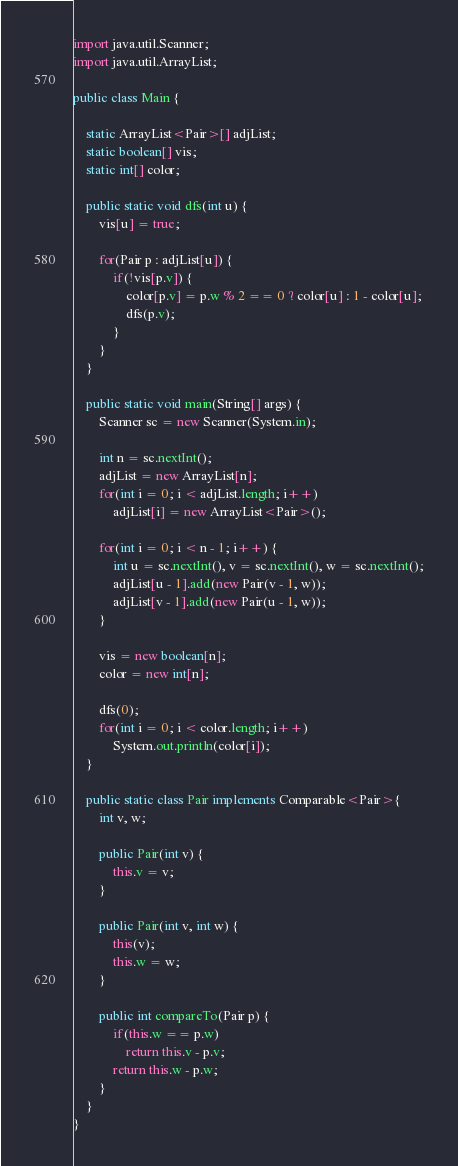Convert code to text. <code><loc_0><loc_0><loc_500><loc_500><_Java_>import java.util.Scanner;
import java.util.ArrayList;

public class Main {
	
	static ArrayList<Pair>[] adjList;
	static boolean[] vis;
	static int[] color;
	
	public static void dfs(int u) {
		vis[u] = true;
		
		for(Pair p : adjList[u]) {
			if(!vis[p.v]) {
				color[p.v] = p.w % 2 == 0 ? color[u] : 1 - color[u];
				dfs(p.v);
			}
		}
	}
	
	public static void main(String[] args) {
		Scanner sc = new Scanner(System.in);
		
		int n = sc.nextInt();
		adjList = new ArrayList[n];
		for(int i = 0; i < adjList.length; i++)
			adjList[i] = new ArrayList<Pair>();
		
		for(int i = 0; i < n - 1; i++) {
			int u = sc.nextInt(), v = sc.nextInt(), w = sc.nextInt();
			adjList[u - 1].add(new Pair(v - 1, w));
			adjList[v - 1].add(new Pair(u - 1, w));
		}
		
		vis = new boolean[n];
		color = new int[n];
		
		dfs(0);
		for(int i = 0; i < color.length; i++)
			System.out.println(color[i]);
	}
	
	public static class Pair implements Comparable<Pair>{
		int v, w;
		
		public Pair(int v) {
			this.v = v;
		}
		
		public Pair(int v, int w) {
			this(v);
			this.w = w;
		}
		
		public int compareTo(Pair p) {
			if(this.w == p.w)
				return this.v - p.v;
			return this.w - p.w;
		}
	}
}
</code> 